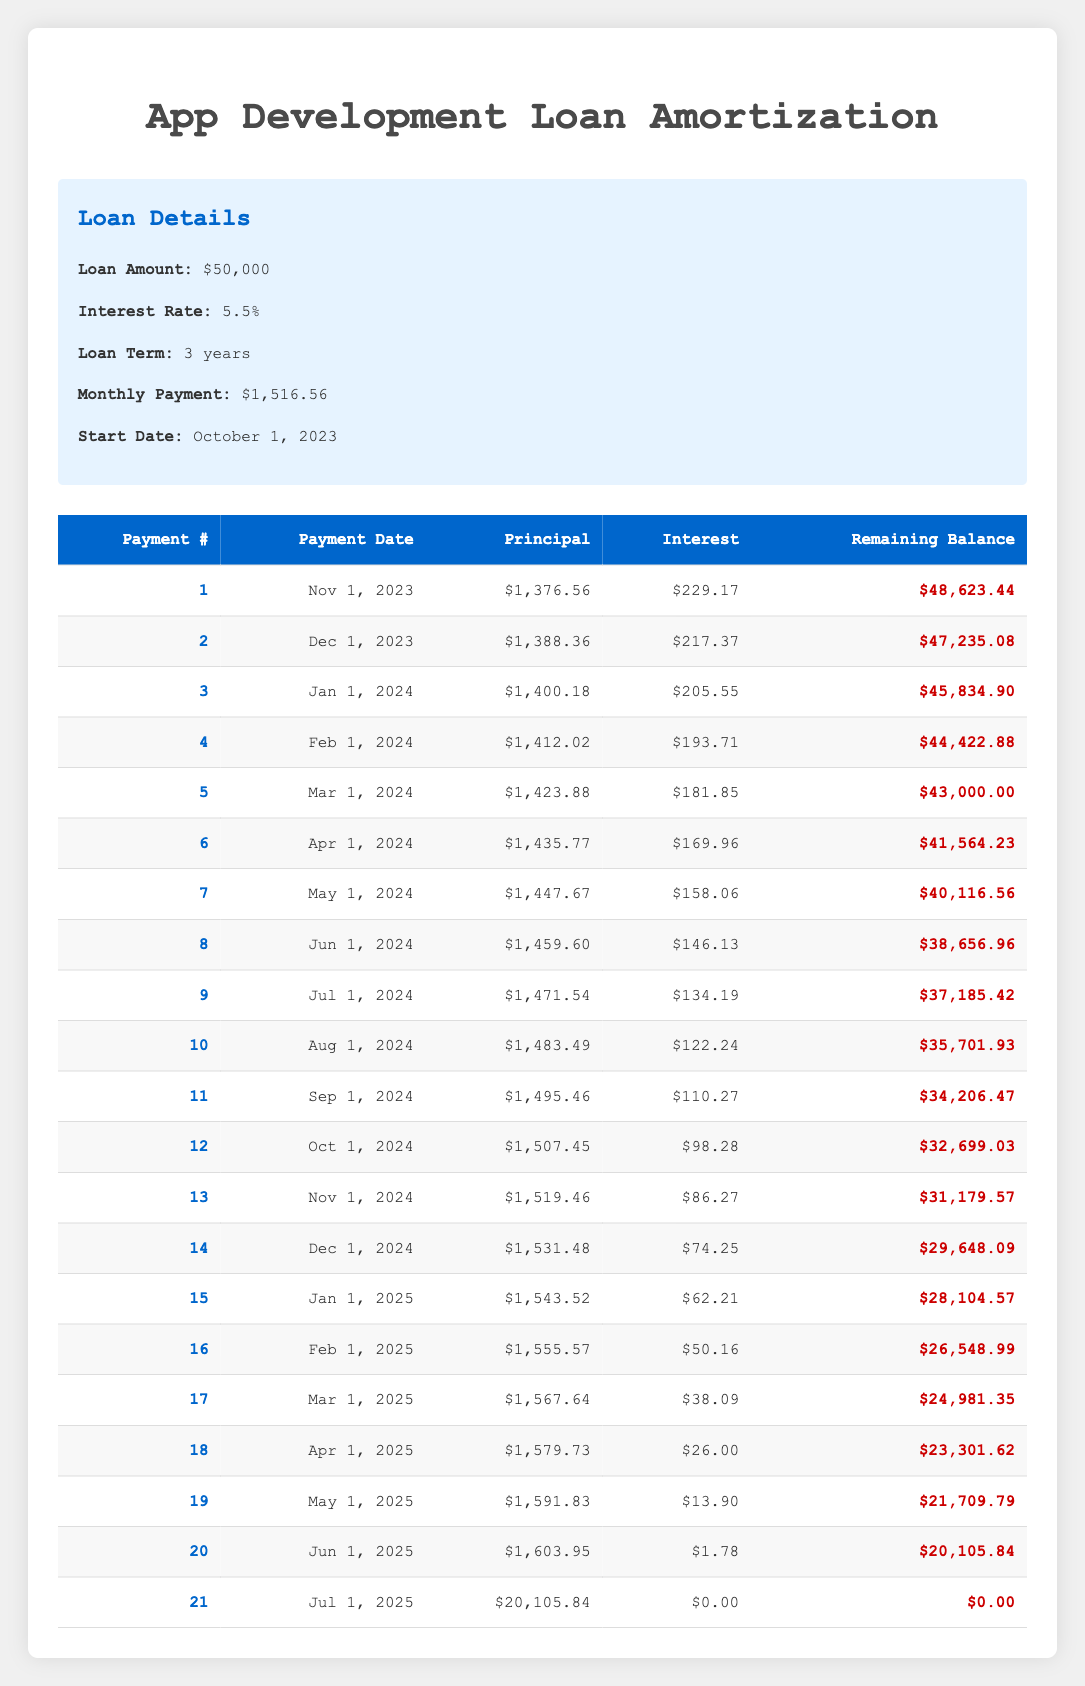What is the principal payment for the 5th payment? The table shows that for the 5th payment, the principal payment is listed as $1,423.88.
Answer: 1,423.88 What is the total interest paid in the first year (first 12 payments)? To find the total interest paid in the first year, we need to sum up the interest payments from payment 1 to payment 12: (229.17 + 217.37 + 205.55 + 193.71 + 181.85 + 169.96 + 158.06 + 146.13 + 134.19 + 122.24 + 110.27 + 98.28) = 1,382.66
Answer: 1,382.66 Is the remaining balance after the 10th payment greater than $36,000? The table lists the remaining balance after the 10th payment as $35,701.93, which is less than $36,000.
Answer: No What was the interest payment for the 4th payment, and how does it compare to the interest payment of the 3rd payment? The interest payment for the 4th payment is $193.71, while for the 3rd payment, it is $205.55. To compare, $193.71 is less than $205.55 by $11.84. Thus, the interest decreased by $11.84.
Answer: $193.71 (decreased by $11.84 from the 3rd payment) What is the average principal payment of the last 5 payments? The last 5 payments include payments from 17 to 21. The principal payments are: $1,567.64, $1,579.73, $1,591.83, $1,603.95, and $20,105.84. The total is: (1,567.64 + 1,579.73 + 1,591.83 + 1,603.95 + 20,105.84) = 26,950.99. There are 5 payments, so the average is: 26,950.99 / 5 = 5,390.20.
Answer: 5,390.20 How much principal was paid off by the 21st payment? By the 21st payment, the remaining balance is $0, which means that the total principal paid off must have equaled the original loan amount of $50,000.
Answer: 50,000 Was the interest payment for the 20th payment the lowest compared to all previous payments? The interest payment for the 20th payment is $1.78. Comparing this with all the previous interest payments, particularly noting the minimum, confirms that it is indeed the lowest payment.
Answer: Yes 